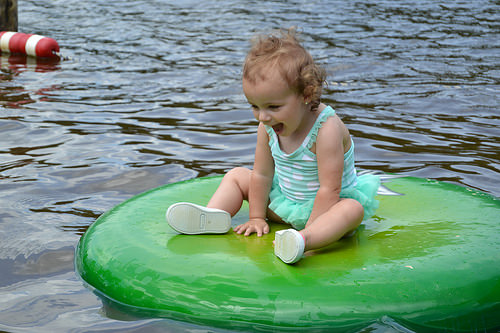<image>
Is the water behind the girl? Yes. From this viewpoint, the water is positioned behind the girl, with the girl partially or fully occluding the water. Is the child next to the water? Yes. The child is positioned adjacent to the water, located nearby in the same general area. Is the kid next to the water? Yes. The kid is positioned adjacent to the water, located nearby in the same general area. 